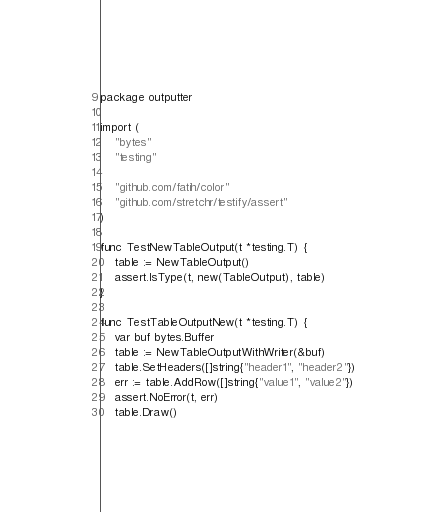<code> <loc_0><loc_0><loc_500><loc_500><_Go_>package outputter

import (
	"bytes"
	"testing"

	"github.com/fatih/color"
	"github.com/stretchr/testify/assert"
)

func TestNewTableOutput(t *testing.T) {
	table := NewTableOutput()
	assert.IsType(t, new(TableOutput), table)
}

func TestTableOutputNew(t *testing.T) {
	var buf bytes.Buffer
	table := NewTableOutputWithWriter(&buf)
	table.SetHeaders([]string{"header1", "header2"})
	err := table.AddRow([]string{"value1", "value2"})
	assert.NoError(t, err)
	table.Draw()</code> 